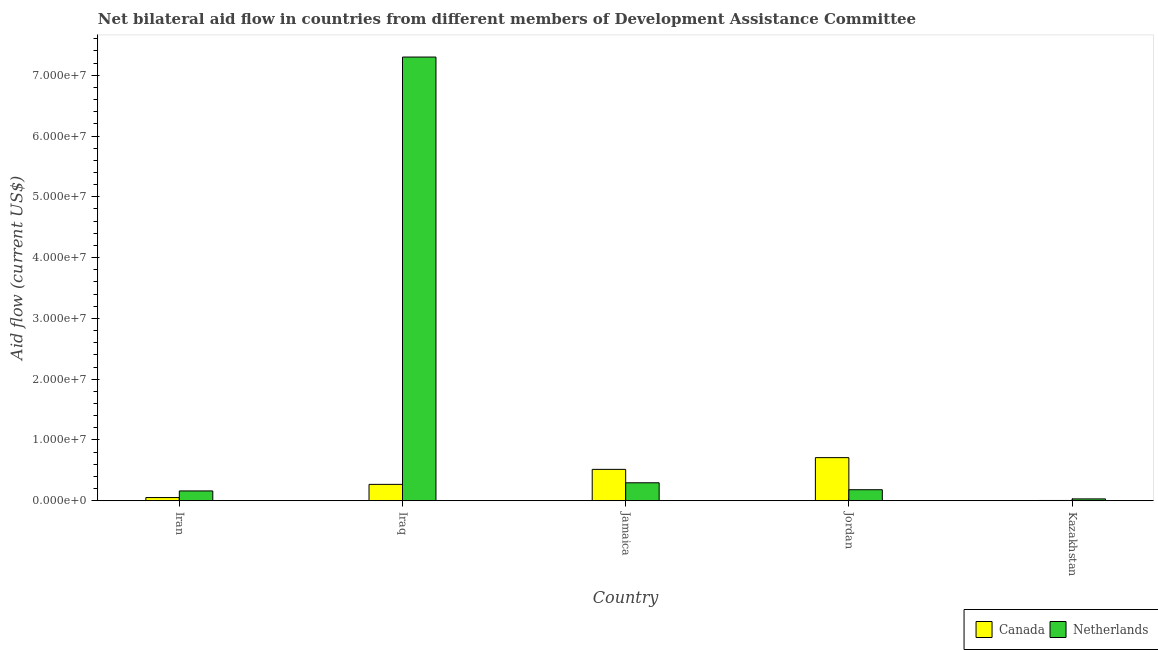Are the number of bars on each tick of the X-axis equal?
Offer a terse response. Yes. What is the label of the 2nd group of bars from the left?
Keep it short and to the point. Iraq. What is the amount of aid given by netherlands in Jamaica?
Your answer should be compact. 2.95e+06. Across all countries, what is the maximum amount of aid given by canada?
Your response must be concise. 7.09e+06. Across all countries, what is the minimum amount of aid given by netherlands?
Make the answer very short. 3.00e+05. In which country was the amount of aid given by canada maximum?
Provide a short and direct response. Jordan. In which country was the amount of aid given by canada minimum?
Your answer should be compact. Kazakhstan. What is the total amount of aid given by canada in the graph?
Offer a terse response. 1.55e+07. What is the difference between the amount of aid given by netherlands in Iraq and that in Kazakhstan?
Offer a very short reply. 7.27e+07. What is the difference between the amount of aid given by netherlands in Iraq and the amount of aid given by canada in Jamaica?
Ensure brevity in your answer.  6.78e+07. What is the average amount of aid given by canada per country?
Keep it short and to the point. 3.10e+06. What is the difference between the amount of aid given by netherlands and amount of aid given by canada in Kazakhstan?
Ensure brevity in your answer.  2.60e+05. What is the ratio of the amount of aid given by netherlands in Jordan to that in Kazakhstan?
Ensure brevity in your answer.  6.03. Is the amount of aid given by netherlands in Iraq less than that in Kazakhstan?
Your response must be concise. No. Is the difference between the amount of aid given by canada in Iraq and Kazakhstan greater than the difference between the amount of aid given by netherlands in Iraq and Kazakhstan?
Provide a succinct answer. No. What is the difference between the highest and the second highest amount of aid given by netherlands?
Offer a terse response. 7.00e+07. What is the difference between the highest and the lowest amount of aid given by canada?
Your answer should be very brief. 7.05e+06. In how many countries, is the amount of aid given by netherlands greater than the average amount of aid given by netherlands taken over all countries?
Give a very brief answer. 1. Is the sum of the amount of aid given by canada in Iran and Jordan greater than the maximum amount of aid given by netherlands across all countries?
Provide a succinct answer. No. What does the 2nd bar from the left in Jordan represents?
Ensure brevity in your answer.  Netherlands. What does the 2nd bar from the right in Jamaica represents?
Your answer should be compact. Canada. How many bars are there?
Your answer should be very brief. 10. Are all the bars in the graph horizontal?
Your response must be concise. No. What is the difference between two consecutive major ticks on the Y-axis?
Make the answer very short. 1.00e+07. Are the values on the major ticks of Y-axis written in scientific E-notation?
Keep it short and to the point. Yes. Does the graph contain grids?
Provide a succinct answer. No. Where does the legend appear in the graph?
Provide a succinct answer. Bottom right. What is the title of the graph?
Make the answer very short. Net bilateral aid flow in countries from different members of Development Assistance Committee. What is the label or title of the X-axis?
Give a very brief answer. Country. What is the Aid flow (current US$) of Canada in Iran?
Offer a terse response. 5.20e+05. What is the Aid flow (current US$) in Netherlands in Iran?
Give a very brief answer. 1.61e+06. What is the Aid flow (current US$) in Canada in Iraq?
Your response must be concise. 2.69e+06. What is the Aid flow (current US$) of Netherlands in Iraq?
Ensure brevity in your answer.  7.30e+07. What is the Aid flow (current US$) of Canada in Jamaica?
Ensure brevity in your answer.  5.16e+06. What is the Aid flow (current US$) of Netherlands in Jamaica?
Provide a succinct answer. 2.95e+06. What is the Aid flow (current US$) of Canada in Jordan?
Your response must be concise. 7.09e+06. What is the Aid flow (current US$) in Netherlands in Jordan?
Make the answer very short. 1.81e+06. What is the Aid flow (current US$) of Canada in Kazakhstan?
Your answer should be compact. 4.00e+04. What is the Aid flow (current US$) of Netherlands in Kazakhstan?
Give a very brief answer. 3.00e+05. Across all countries, what is the maximum Aid flow (current US$) in Canada?
Make the answer very short. 7.09e+06. Across all countries, what is the maximum Aid flow (current US$) in Netherlands?
Provide a short and direct response. 7.30e+07. Across all countries, what is the minimum Aid flow (current US$) in Netherlands?
Provide a succinct answer. 3.00e+05. What is the total Aid flow (current US$) in Canada in the graph?
Your response must be concise. 1.55e+07. What is the total Aid flow (current US$) in Netherlands in the graph?
Your answer should be very brief. 7.97e+07. What is the difference between the Aid flow (current US$) in Canada in Iran and that in Iraq?
Provide a succinct answer. -2.17e+06. What is the difference between the Aid flow (current US$) in Netherlands in Iran and that in Iraq?
Keep it short and to the point. -7.14e+07. What is the difference between the Aid flow (current US$) in Canada in Iran and that in Jamaica?
Offer a terse response. -4.64e+06. What is the difference between the Aid flow (current US$) in Netherlands in Iran and that in Jamaica?
Provide a succinct answer. -1.34e+06. What is the difference between the Aid flow (current US$) in Canada in Iran and that in Jordan?
Make the answer very short. -6.57e+06. What is the difference between the Aid flow (current US$) in Netherlands in Iran and that in Jordan?
Provide a short and direct response. -2.00e+05. What is the difference between the Aid flow (current US$) in Netherlands in Iran and that in Kazakhstan?
Offer a very short reply. 1.31e+06. What is the difference between the Aid flow (current US$) of Canada in Iraq and that in Jamaica?
Your answer should be compact. -2.47e+06. What is the difference between the Aid flow (current US$) of Netherlands in Iraq and that in Jamaica?
Give a very brief answer. 7.00e+07. What is the difference between the Aid flow (current US$) in Canada in Iraq and that in Jordan?
Provide a succinct answer. -4.40e+06. What is the difference between the Aid flow (current US$) of Netherlands in Iraq and that in Jordan?
Your answer should be compact. 7.12e+07. What is the difference between the Aid flow (current US$) of Canada in Iraq and that in Kazakhstan?
Provide a short and direct response. 2.65e+06. What is the difference between the Aid flow (current US$) of Netherlands in Iraq and that in Kazakhstan?
Your answer should be compact. 7.27e+07. What is the difference between the Aid flow (current US$) in Canada in Jamaica and that in Jordan?
Provide a short and direct response. -1.93e+06. What is the difference between the Aid flow (current US$) of Netherlands in Jamaica and that in Jordan?
Make the answer very short. 1.14e+06. What is the difference between the Aid flow (current US$) in Canada in Jamaica and that in Kazakhstan?
Keep it short and to the point. 5.12e+06. What is the difference between the Aid flow (current US$) of Netherlands in Jamaica and that in Kazakhstan?
Your response must be concise. 2.65e+06. What is the difference between the Aid flow (current US$) in Canada in Jordan and that in Kazakhstan?
Ensure brevity in your answer.  7.05e+06. What is the difference between the Aid flow (current US$) in Netherlands in Jordan and that in Kazakhstan?
Offer a terse response. 1.51e+06. What is the difference between the Aid flow (current US$) of Canada in Iran and the Aid flow (current US$) of Netherlands in Iraq?
Offer a terse response. -7.25e+07. What is the difference between the Aid flow (current US$) in Canada in Iran and the Aid flow (current US$) in Netherlands in Jamaica?
Ensure brevity in your answer.  -2.43e+06. What is the difference between the Aid flow (current US$) in Canada in Iran and the Aid flow (current US$) in Netherlands in Jordan?
Your answer should be compact. -1.29e+06. What is the difference between the Aid flow (current US$) of Canada in Iraq and the Aid flow (current US$) of Netherlands in Jordan?
Offer a very short reply. 8.80e+05. What is the difference between the Aid flow (current US$) in Canada in Iraq and the Aid flow (current US$) in Netherlands in Kazakhstan?
Offer a terse response. 2.39e+06. What is the difference between the Aid flow (current US$) in Canada in Jamaica and the Aid flow (current US$) in Netherlands in Jordan?
Your answer should be very brief. 3.35e+06. What is the difference between the Aid flow (current US$) in Canada in Jamaica and the Aid flow (current US$) in Netherlands in Kazakhstan?
Your answer should be very brief. 4.86e+06. What is the difference between the Aid flow (current US$) in Canada in Jordan and the Aid flow (current US$) in Netherlands in Kazakhstan?
Make the answer very short. 6.79e+06. What is the average Aid flow (current US$) of Canada per country?
Make the answer very short. 3.10e+06. What is the average Aid flow (current US$) in Netherlands per country?
Your response must be concise. 1.59e+07. What is the difference between the Aid flow (current US$) in Canada and Aid flow (current US$) in Netherlands in Iran?
Provide a succinct answer. -1.09e+06. What is the difference between the Aid flow (current US$) of Canada and Aid flow (current US$) of Netherlands in Iraq?
Give a very brief answer. -7.03e+07. What is the difference between the Aid flow (current US$) in Canada and Aid flow (current US$) in Netherlands in Jamaica?
Make the answer very short. 2.21e+06. What is the difference between the Aid flow (current US$) in Canada and Aid flow (current US$) in Netherlands in Jordan?
Give a very brief answer. 5.28e+06. What is the difference between the Aid flow (current US$) in Canada and Aid flow (current US$) in Netherlands in Kazakhstan?
Provide a succinct answer. -2.60e+05. What is the ratio of the Aid flow (current US$) of Canada in Iran to that in Iraq?
Your answer should be very brief. 0.19. What is the ratio of the Aid flow (current US$) of Netherlands in Iran to that in Iraq?
Your answer should be compact. 0.02. What is the ratio of the Aid flow (current US$) of Canada in Iran to that in Jamaica?
Ensure brevity in your answer.  0.1. What is the ratio of the Aid flow (current US$) in Netherlands in Iran to that in Jamaica?
Provide a short and direct response. 0.55. What is the ratio of the Aid flow (current US$) of Canada in Iran to that in Jordan?
Make the answer very short. 0.07. What is the ratio of the Aid flow (current US$) in Netherlands in Iran to that in Jordan?
Provide a succinct answer. 0.89. What is the ratio of the Aid flow (current US$) of Canada in Iran to that in Kazakhstan?
Give a very brief answer. 13. What is the ratio of the Aid flow (current US$) of Netherlands in Iran to that in Kazakhstan?
Your answer should be very brief. 5.37. What is the ratio of the Aid flow (current US$) of Canada in Iraq to that in Jamaica?
Make the answer very short. 0.52. What is the ratio of the Aid flow (current US$) of Netherlands in Iraq to that in Jamaica?
Your response must be concise. 24.75. What is the ratio of the Aid flow (current US$) of Canada in Iraq to that in Jordan?
Provide a short and direct response. 0.38. What is the ratio of the Aid flow (current US$) of Netherlands in Iraq to that in Jordan?
Give a very brief answer. 40.33. What is the ratio of the Aid flow (current US$) in Canada in Iraq to that in Kazakhstan?
Offer a terse response. 67.25. What is the ratio of the Aid flow (current US$) of Netherlands in Iraq to that in Kazakhstan?
Ensure brevity in your answer.  243.33. What is the ratio of the Aid flow (current US$) of Canada in Jamaica to that in Jordan?
Offer a very short reply. 0.73. What is the ratio of the Aid flow (current US$) of Netherlands in Jamaica to that in Jordan?
Give a very brief answer. 1.63. What is the ratio of the Aid flow (current US$) of Canada in Jamaica to that in Kazakhstan?
Your answer should be compact. 129. What is the ratio of the Aid flow (current US$) of Netherlands in Jamaica to that in Kazakhstan?
Provide a succinct answer. 9.83. What is the ratio of the Aid flow (current US$) of Canada in Jordan to that in Kazakhstan?
Provide a short and direct response. 177.25. What is the ratio of the Aid flow (current US$) in Netherlands in Jordan to that in Kazakhstan?
Your answer should be compact. 6.03. What is the difference between the highest and the second highest Aid flow (current US$) of Canada?
Your response must be concise. 1.93e+06. What is the difference between the highest and the second highest Aid flow (current US$) of Netherlands?
Ensure brevity in your answer.  7.00e+07. What is the difference between the highest and the lowest Aid flow (current US$) in Canada?
Provide a short and direct response. 7.05e+06. What is the difference between the highest and the lowest Aid flow (current US$) of Netherlands?
Offer a very short reply. 7.27e+07. 